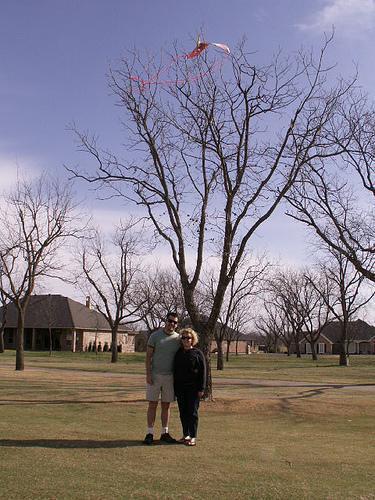How many people?
Give a very brief answer. 2. How many people are there?
Give a very brief answer. 2. 